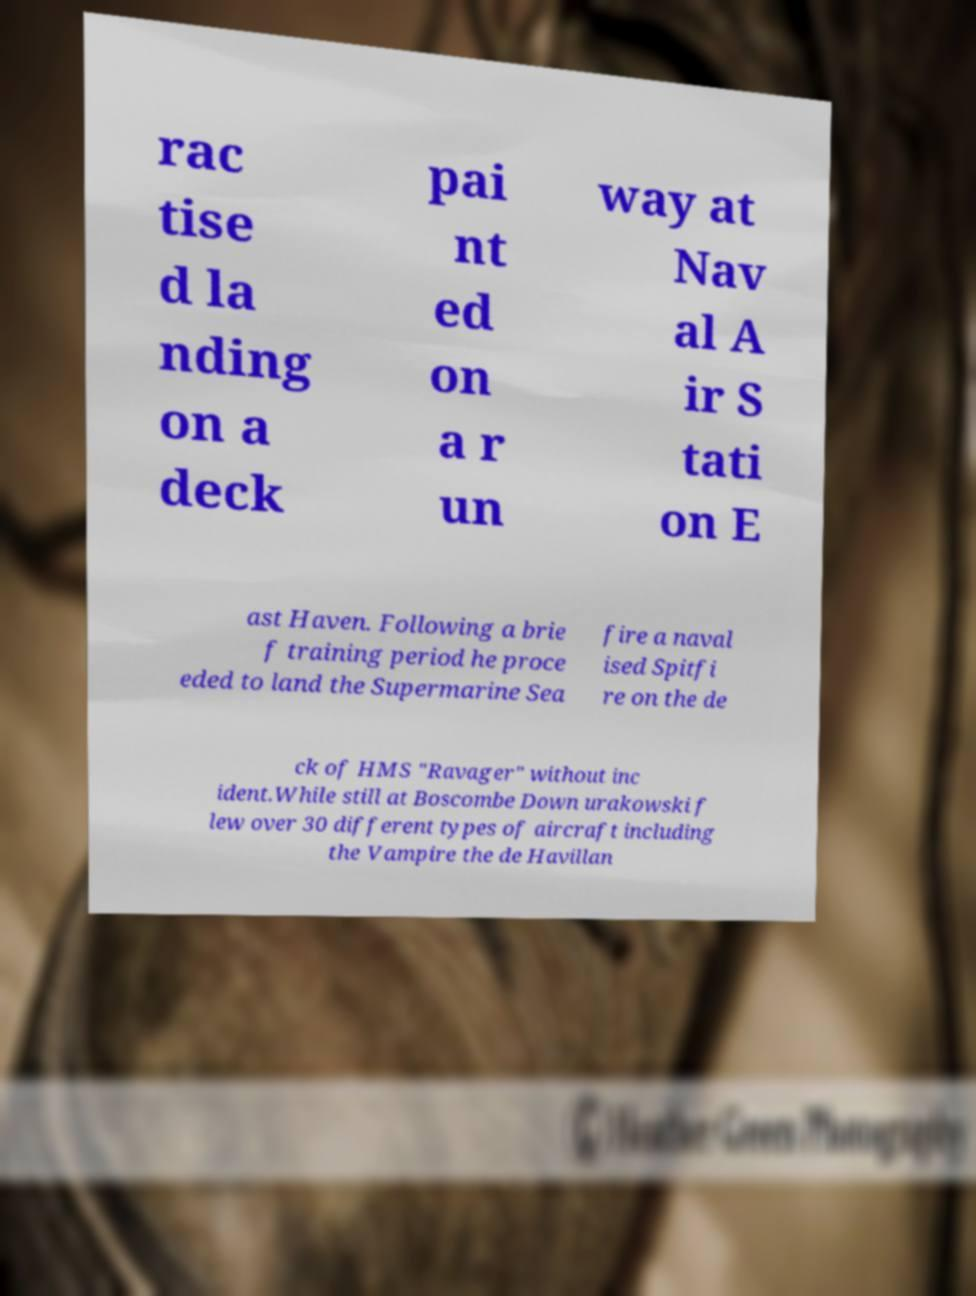Can you accurately transcribe the text from the provided image for me? rac tise d la nding on a deck pai nt ed on a r un way at Nav al A ir S tati on E ast Haven. Following a brie f training period he proce eded to land the Supermarine Sea fire a naval ised Spitfi re on the de ck of HMS "Ravager" without inc ident.While still at Boscombe Down urakowski f lew over 30 different types of aircraft including the Vampire the de Havillan 